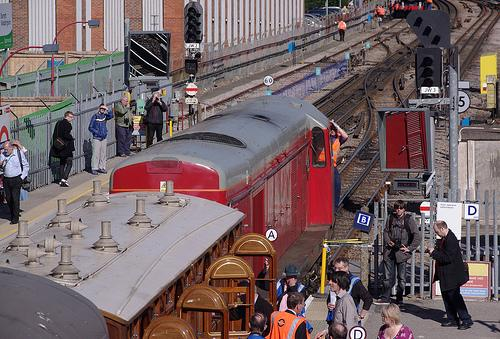What is the most striking aspect of the train depicted in the image? The red engine of the train is the most striking aspect since it has a width of 273 and a height of 273. Mention two people in the image and briefly describe what they are wearing. A man in a black suit is present, as well as a man wearing an orange safety vest. Both men have a width and height of 62 and 59, respectively. Explain what is happening in the scene at the train station. People are waiting for the train on the platform, and a train has just arrived at the station. Some individuals are wearing safety vests, and there are various elements such as railway tracks, signal poles, and fencing. List three objects in the image along with their colors and sizes. The red engine of the train has a width of 273 and a height of 273, the man in a black suit has a width of 62 and a height of 62, and the wooden slats between tracks have a width of 12 and a height of 12. Describe the scene in the image. The scene shows multiple people standing on a platform, a train arriving at the station, and various signs and objects related to a train station. Is the man in the black suit standing at X:371 Y:189 with Width:51 and Height:51? The man in the black suit is actually at X:418 Y:206 with Width:62 and Height:62. Describe the color and shape of the train car. The train car is red and gray with a rectangular shape. What is the color of the train's roof? The train's roof is gray. Are there people standing on the platform at X:271 Y:235 with Width:111 and Height:111? The people standing on the platform are actually at X:271 Y:235 with Width:141 and Height:141. Find any anomalies in the image. There are no apparent anomalies in the image. Is the passenger car located at X:0 Y:172 with Width:166 and Height:166? The passenger car is actually at X:0 Y:172 with Width:266 and Height:266. Describe the text on the white square and round sign. Black letter on white square (X:463, Y:201, Width:17, Height:17), letter on round sign (X:264, Y:226, Width:16, Height:16) Is there a traffic light near the train? Yes, there is a traffic light near the train at X:189, Y:7, Width:12, Height:12. Is there a man in an orange vest at X:263 Y:294 with Width:58 and Height:58? The man in the orange vest is actually at X:263 Y:294 with Width:48 and Height:48. Indicate the position of the wooden slats between the train tracks. X:362, Y:176, Width:12, Height:12 Are there more than three people on the platform? Yes, there are more than three people on the platform. List all the objects and their positions in the image. Man (X:421, Y:215), Train (X:0, Y:16), People waiting (X:0, Y:32), Sign (X:182, Y:76), Man in black suit (X:418, Y:206), Man wearing orange vest (X:255, Y:275), Train engine (X:105, Y:67), Railway tracks (X:337, Y:3), Signal (X:180, Y:0), Passenger car (X:0, Y:172), Traffic light (X:189, Y:7), Shadow on platform (X:417, Y:305), Wooden slats (X:362, Y:176), Door (X:315, Y:176), Bag (X:47, Y:133), Top of the train (X:208, Y:119), Fences (X:484, Y:203, X:20, Y:107, X:18, Y:78), Camera (X:378, Y:200), Letters and signs (X:463, Y:201, X:264, Y:226), Light pole (X:50, Y:17) Which object is larger: the train or the man in an orange vest? The train is larger. What type of vest is the man wearing near the train? The man is wearing a neon orange safety vest. Can you find a green train car at X:109 Y:99 with Width:227 and Height:227? The train car at this location is actually red and gray, not green. How many railway tracks can be seen in the image? Intersecting train tracks (X:326, Y:62, Width:82, Height:82), regular railway tracks (X:337, Y:3, Width:152, Height:152) What is the color of the fence near the train tracks? The fence is gray. What is the overall sentiment evoked by the image? The overall sentiment evoked by the image is neutral or calm. Can you see a blue fence near the tracks at X:297 Y:78 with Width:26 and Height:26? The blue fence is actually at X:297 Y:78 with Width:16 and Height:16. Identify the interaction between the people and the train in this image. The people are waiting for the train on the platform, and the train is arriving at the station. Locate the object mentioned in the following description: "man wearing an orange safety vest". X:255, Y:275, Width:59, Height:59 Critique the image quality. The image is clear, has good resolution, and depicts various objects and details in the scene with sufficient clarity. 